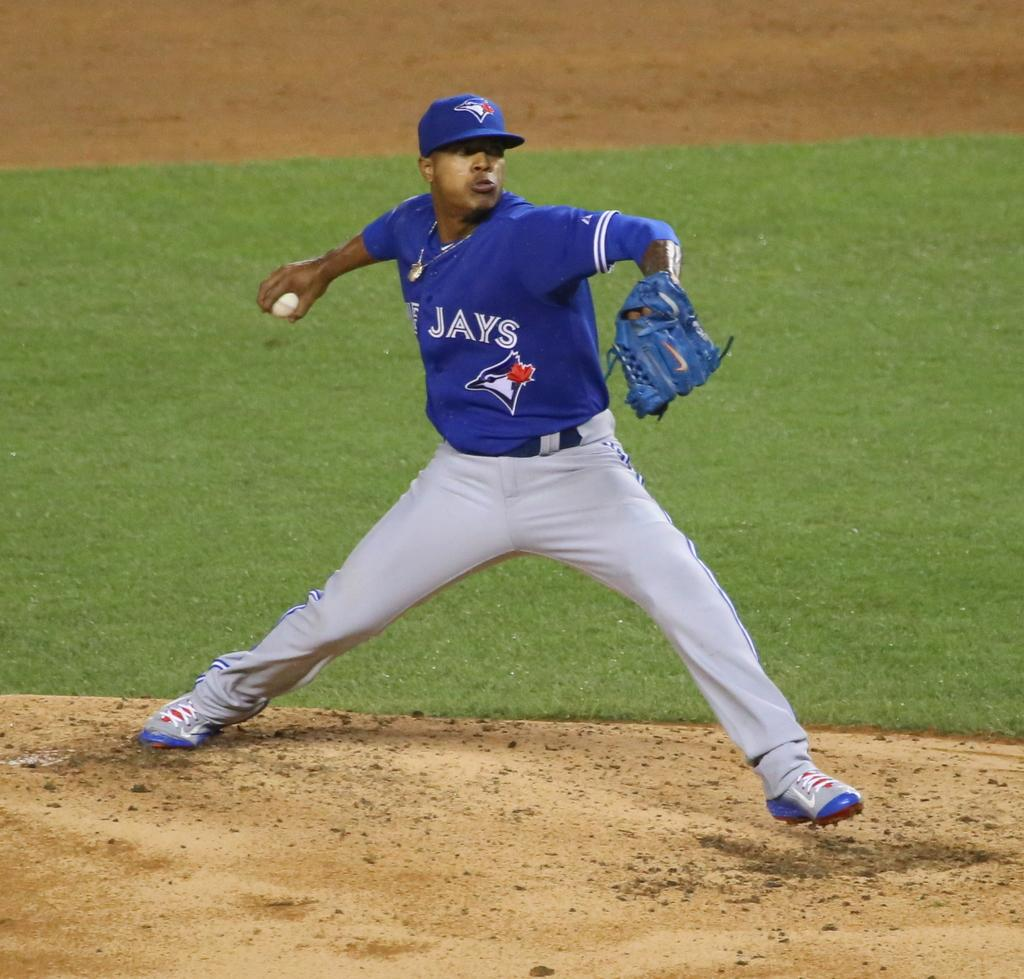<image>
Provide a brief description of the given image. A baseball pitcher wears a blue shirt with Jays on it. 